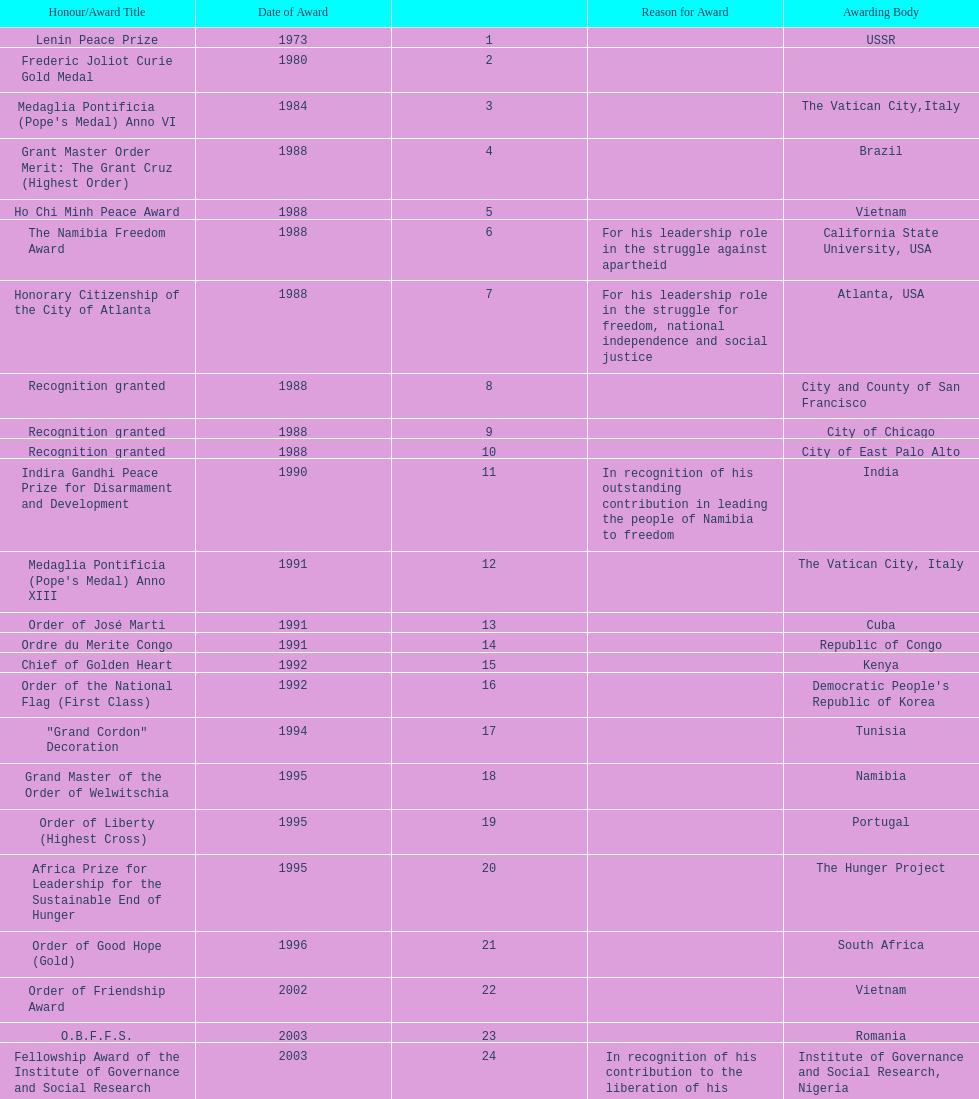What is the latest award that nujoma has been given? Sir Seretse Khama SADC Meda. 